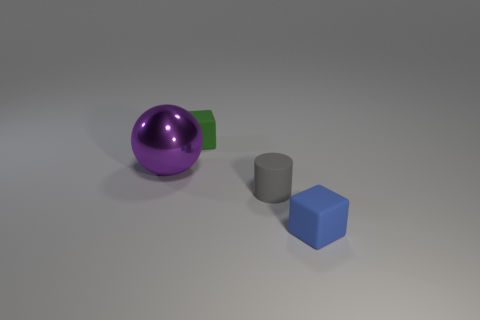What number of gray things are either cubes or small cylinders?
Offer a very short reply. 1. There is a cube to the left of the small blue object that is in front of the thing that is behind the purple metallic ball; what is its size?
Your answer should be compact. Small. How many big things are either rubber things or metal things?
Offer a very short reply. 1. Is the material of the cube that is behind the metal object the same as the thing in front of the tiny cylinder?
Give a very brief answer. Yes. What is the material of the object that is on the left side of the green rubber thing?
Provide a succinct answer. Metal. What number of matte objects are green objects or big purple things?
Make the answer very short. 1. What is the color of the tiny matte cube that is right of the tiny thing behind the small gray cylinder?
Your answer should be compact. Blue. Do the tiny green cube and the small block that is in front of the large shiny thing have the same material?
Offer a terse response. Yes. What is the color of the large metal sphere in front of the tiny matte block that is left of the rubber block that is to the right of the gray matte object?
Provide a short and direct response. Purple. Is there anything else that is the same shape as the tiny gray rubber thing?
Provide a succinct answer. No. 